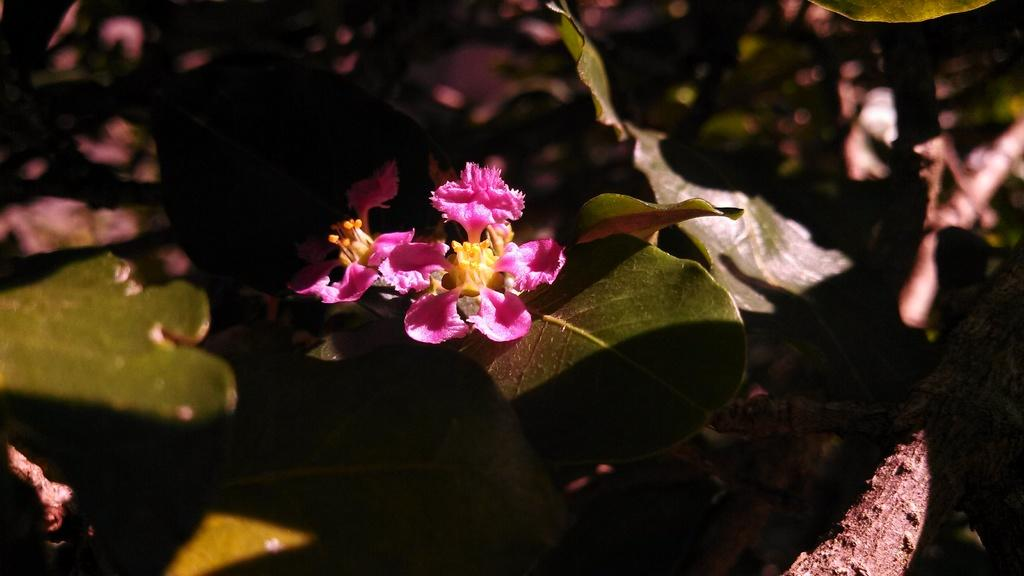What is the main subject of the image? The main subject of the image is a plant. What color are the flowers on the plant? The flowers on the plant are pink. Can you describe the background of the image? The background of the image is blurred. Is there a horse running down a slope in the image? No, there is no horse or slope present in the image; it features a plant with pink flowers against a blurred background. 